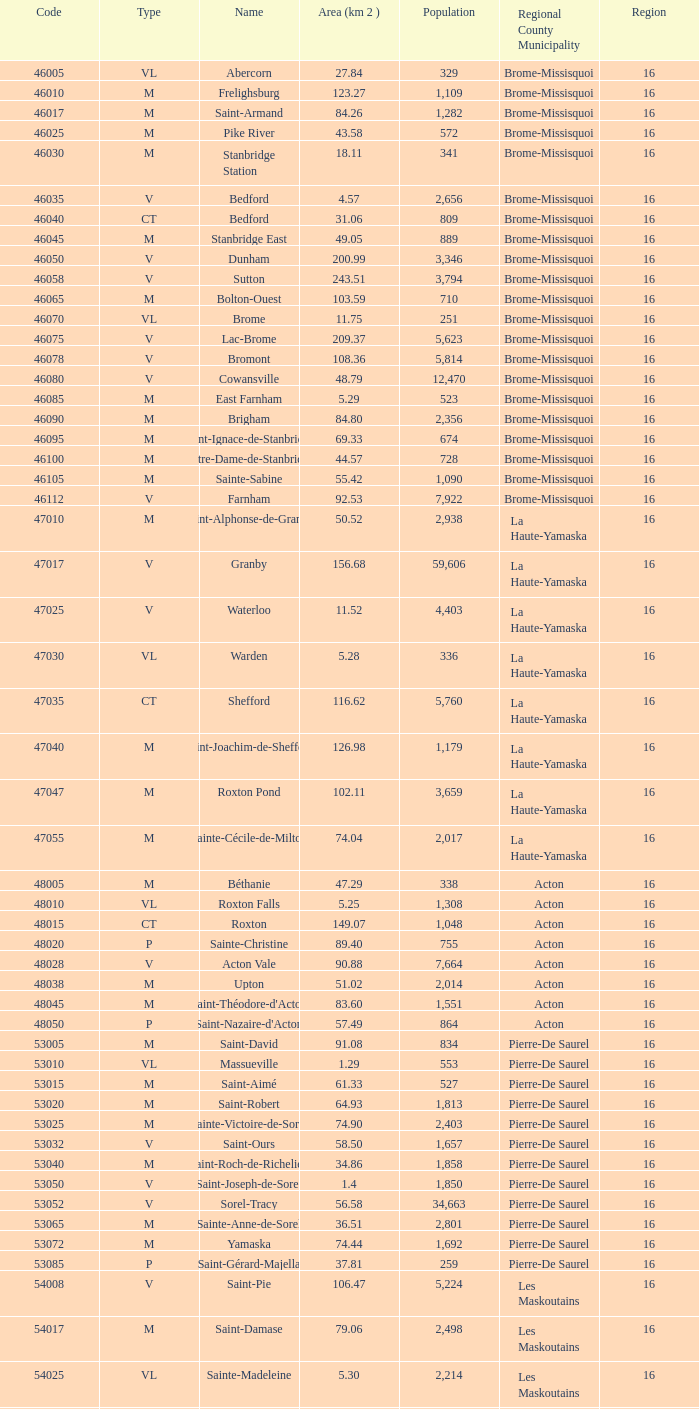What is the population of cowansville, a brome-missisquoi municipality with fewer than 16 regions? None. 